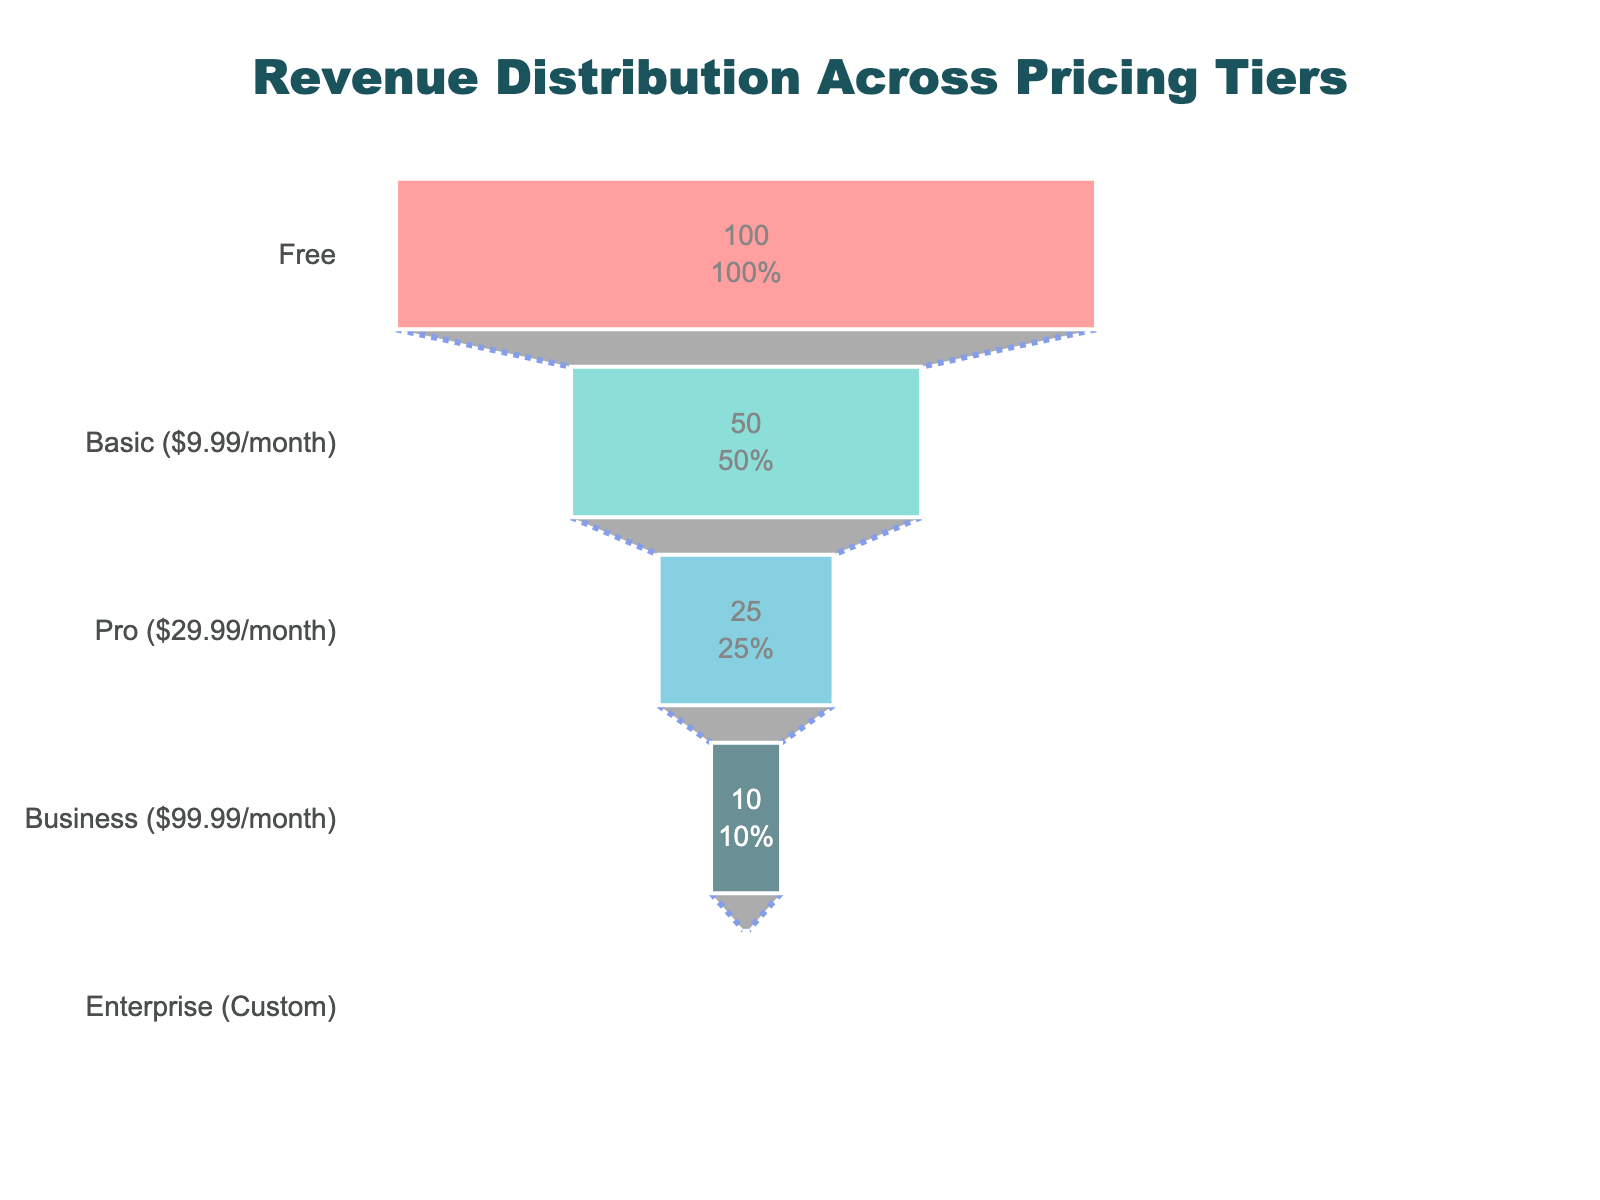What is the title of the funnel chart? The title is displayed at the top of the funnel chart. Reading the title directly, we see "Revenue Distribution Across Pricing Tiers".
Answer: Revenue Distribution Across Pricing Tiers What is the color of the segment representing the 'Pro' tier? Each tier is represented by a different color segment. The 'Pro' tier is marked with a blue color.
Answer: Blue How many users are on the 'Free' tier? The number of users for each tier is indicated on the chart. Referring to the top segment representing the 'Free' tier, there are 100,000 users.
Answer: 100,000 What is the percentage of users in the 'Basic' tier relative to the total number of users in the 'Free' tier? The 'Basic' tier segment shows its percentage relative to the maximum users. The 'Basic' tier has 50% of the users as the 'Free' tier. Therefore, it’s 50%.
Answer: 50% Which tier generates the highest revenue? By looking at the contextual annotations showing the revenue, the 'Enterprise' tier generates the highest revenue with $2,500,000.
Answer: Enterprise What is the total revenue generated by all tiers except the 'Free' tier? Summing up the revenue from Basic, Pro, Business, and Enterprise tiers: 499500 + 749750 + 999900 + 2500000 = 4749150.
Answer: 4,749,150 By how much does the revenue from the 'Business' tier exceed that from the 'Pro' tier? Calculate the difference between the revenues of 'Business' tier ($999,900) and 'Pro' tier ($749,750): 999900 - 749750 = 250150. Therefore, the 'Business' tier exceeds the 'Pro' tier by $250,150.
Answer: 250,150 Between which two tiers is the drop in the number of users the largest? Comparing the drop in users between successive tiers, the largest drop is between the 'Free' tier (100,000 users) and the 'Basic' tier (50,000 users), which is a decrease of 50,000 users.
Answer: Free and Basic What is the average revenue generated per user in the 'Enterprise' tier? The 'Enterprise' tier generates $2,500,000 in revenue with 500 users. Dividing the revenue by the number of users: 2500000 / 500 = 5000.
Answer: 5,000 Which tier has the smallest number of users? The segment with the smallest width and user annotation indicates the 'Enterprise' tier, which has 500 users.
Answer: Enterprise 